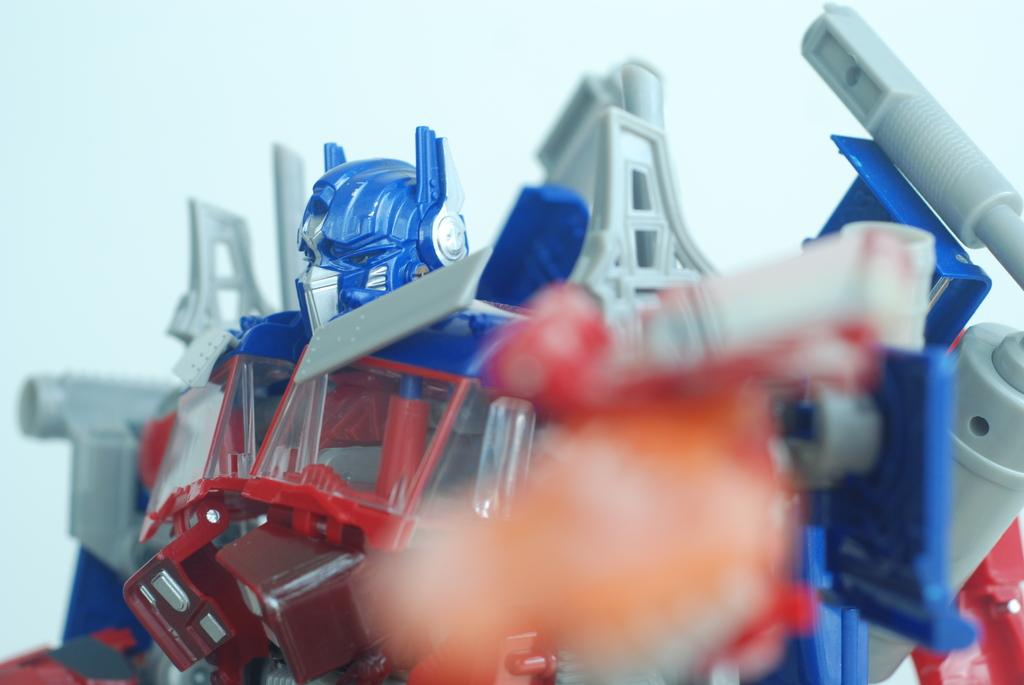What is the main subject in the image? There is a toy robot in the image. What color is the background of the image? The background of the image is white in color. Can you hear the fireman crying in the image? There is no fireman or crying sound present in the image, as it only features a toy robot against a white background. 